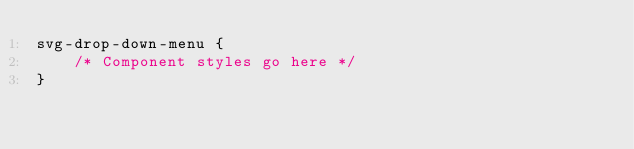Convert code to text. <code><loc_0><loc_0><loc_500><loc_500><_CSS_>svg-drop-down-menu {
    /* Component styles go here */
}
</code> 